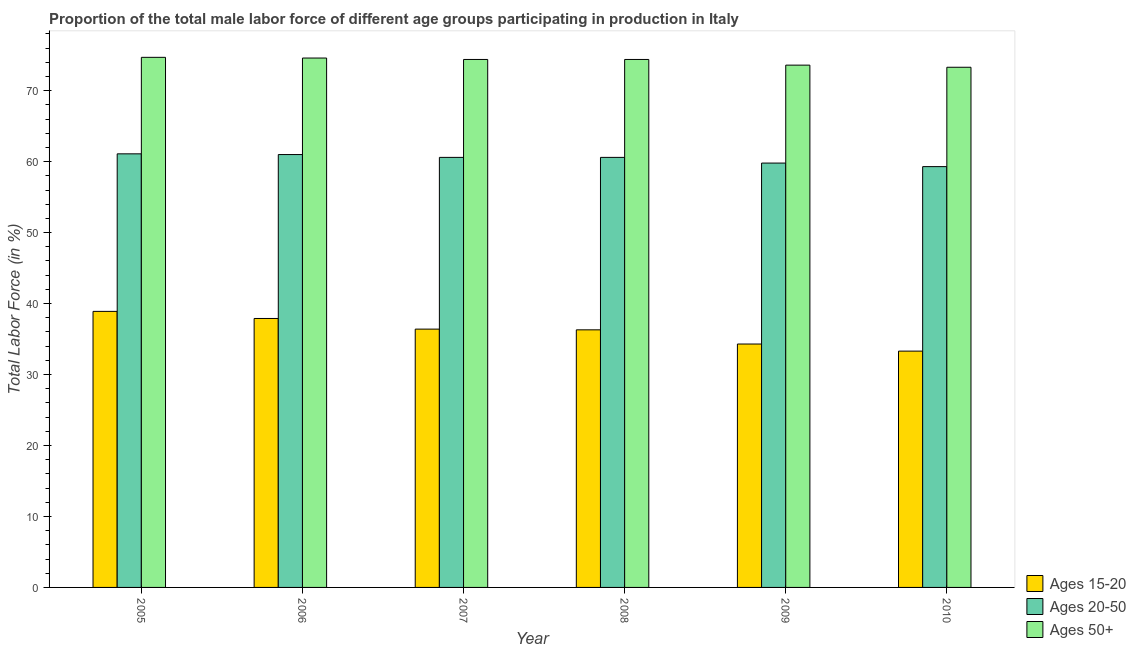How many different coloured bars are there?
Your answer should be very brief. 3. How many groups of bars are there?
Ensure brevity in your answer.  6. Are the number of bars per tick equal to the number of legend labels?
Provide a succinct answer. Yes. Are the number of bars on each tick of the X-axis equal?
Make the answer very short. Yes. How many bars are there on the 5th tick from the left?
Your answer should be very brief. 3. How many bars are there on the 2nd tick from the right?
Your answer should be compact. 3. What is the label of the 5th group of bars from the left?
Provide a short and direct response. 2009. What is the percentage of male labor force within the age group 15-20 in 2008?
Provide a succinct answer. 36.3. Across all years, what is the maximum percentage of male labor force within the age group 15-20?
Give a very brief answer. 38.9. Across all years, what is the minimum percentage of male labor force above age 50?
Provide a succinct answer. 73.3. In which year was the percentage of male labor force within the age group 20-50 maximum?
Offer a very short reply. 2005. What is the total percentage of male labor force within the age group 20-50 in the graph?
Provide a succinct answer. 362.4. What is the difference between the percentage of male labor force within the age group 15-20 in 2009 and that in 2010?
Your answer should be very brief. 1. What is the difference between the percentage of male labor force above age 50 in 2007 and the percentage of male labor force within the age group 15-20 in 2009?
Provide a succinct answer. 0.8. What is the average percentage of male labor force within the age group 20-50 per year?
Offer a very short reply. 60.4. In the year 2005, what is the difference between the percentage of male labor force above age 50 and percentage of male labor force within the age group 15-20?
Your answer should be very brief. 0. What is the ratio of the percentage of male labor force within the age group 15-20 in 2005 to that in 2007?
Keep it short and to the point. 1.07. Is the percentage of male labor force above age 50 in 2006 less than that in 2008?
Offer a terse response. No. Is the difference between the percentage of male labor force within the age group 20-50 in 2007 and 2010 greater than the difference between the percentage of male labor force within the age group 15-20 in 2007 and 2010?
Your response must be concise. No. What is the difference between the highest and the second highest percentage of male labor force within the age group 20-50?
Keep it short and to the point. 0.1. What is the difference between the highest and the lowest percentage of male labor force above age 50?
Provide a succinct answer. 1.4. In how many years, is the percentage of male labor force above age 50 greater than the average percentage of male labor force above age 50 taken over all years?
Offer a very short reply. 4. Is the sum of the percentage of male labor force within the age group 20-50 in 2008 and 2010 greater than the maximum percentage of male labor force above age 50 across all years?
Offer a very short reply. Yes. What does the 3rd bar from the left in 2007 represents?
Your answer should be compact. Ages 50+. What does the 3rd bar from the right in 2009 represents?
Make the answer very short. Ages 15-20. How many bars are there?
Your answer should be very brief. 18. Are all the bars in the graph horizontal?
Offer a terse response. No. How many years are there in the graph?
Ensure brevity in your answer.  6. Does the graph contain any zero values?
Your response must be concise. No. Does the graph contain grids?
Provide a succinct answer. No. How many legend labels are there?
Offer a terse response. 3. How are the legend labels stacked?
Your answer should be compact. Vertical. What is the title of the graph?
Keep it short and to the point. Proportion of the total male labor force of different age groups participating in production in Italy. Does "Female employers" appear as one of the legend labels in the graph?
Give a very brief answer. No. What is the label or title of the X-axis?
Make the answer very short. Year. What is the label or title of the Y-axis?
Offer a very short reply. Total Labor Force (in %). What is the Total Labor Force (in %) of Ages 15-20 in 2005?
Provide a succinct answer. 38.9. What is the Total Labor Force (in %) of Ages 20-50 in 2005?
Make the answer very short. 61.1. What is the Total Labor Force (in %) of Ages 50+ in 2005?
Provide a short and direct response. 74.7. What is the Total Labor Force (in %) in Ages 15-20 in 2006?
Keep it short and to the point. 37.9. What is the Total Labor Force (in %) of Ages 50+ in 2006?
Make the answer very short. 74.6. What is the Total Labor Force (in %) in Ages 15-20 in 2007?
Keep it short and to the point. 36.4. What is the Total Labor Force (in %) of Ages 20-50 in 2007?
Your answer should be compact. 60.6. What is the Total Labor Force (in %) in Ages 50+ in 2007?
Provide a short and direct response. 74.4. What is the Total Labor Force (in %) in Ages 15-20 in 2008?
Provide a short and direct response. 36.3. What is the Total Labor Force (in %) of Ages 20-50 in 2008?
Your response must be concise. 60.6. What is the Total Labor Force (in %) of Ages 50+ in 2008?
Provide a short and direct response. 74.4. What is the Total Labor Force (in %) of Ages 15-20 in 2009?
Your response must be concise. 34.3. What is the Total Labor Force (in %) of Ages 20-50 in 2009?
Your answer should be compact. 59.8. What is the Total Labor Force (in %) of Ages 50+ in 2009?
Keep it short and to the point. 73.6. What is the Total Labor Force (in %) in Ages 15-20 in 2010?
Offer a very short reply. 33.3. What is the Total Labor Force (in %) of Ages 20-50 in 2010?
Your answer should be compact. 59.3. What is the Total Labor Force (in %) in Ages 50+ in 2010?
Offer a very short reply. 73.3. Across all years, what is the maximum Total Labor Force (in %) in Ages 15-20?
Offer a very short reply. 38.9. Across all years, what is the maximum Total Labor Force (in %) in Ages 20-50?
Your answer should be compact. 61.1. Across all years, what is the maximum Total Labor Force (in %) of Ages 50+?
Offer a terse response. 74.7. Across all years, what is the minimum Total Labor Force (in %) of Ages 15-20?
Offer a terse response. 33.3. Across all years, what is the minimum Total Labor Force (in %) in Ages 20-50?
Make the answer very short. 59.3. Across all years, what is the minimum Total Labor Force (in %) in Ages 50+?
Offer a very short reply. 73.3. What is the total Total Labor Force (in %) of Ages 15-20 in the graph?
Ensure brevity in your answer.  217.1. What is the total Total Labor Force (in %) in Ages 20-50 in the graph?
Offer a terse response. 362.4. What is the total Total Labor Force (in %) of Ages 50+ in the graph?
Provide a short and direct response. 445. What is the difference between the Total Labor Force (in %) in Ages 20-50 in 2005 and that in 2006?
Offer a very short reply. 0.1. What is the difference between the Total Labor Force (in %) in Ages 50+ in 2005 and that in 2008?
Keep it short and to the point. 0.3. What is the difference between the Total Labor Force (in %) of Ages 15-20 in 2005 and that in 2009?
Your answer should be compact. 4.6. What is the difference between the Total Labor Force (in %) in Ages 50+ in 2005 and that in 2009?
Make the answer very short. 1.1. What is the difference between the Total Labor Force (in %) of Ages 15-20 in 2005 and that in 2010?
Keep it short and to the point. 5.6. What is the difference between the Total Labor Force (in %) in Ages 50+ in 2005 and that in 2010?
Your answer should be compact. 1.4. What is the difference between the Total Labor Force (in %) of Ages 15-20 in 2006 and that in 2007?
Keep it short and to the point. 1.5. What is the difference between the Total Labor Force (in %) of Ages 20-50 in 2006 and that in 2007?
Offer a very short reply. 0.4. What is the difference between the Total Labor Force (in %) in Ages 15-20 in 2006 and that in 2009?
Your answer should be compact. 3.6. What is the difference between the Total Labor Force (in %) in Ages 15-20 in 2006 and that in 2010?
Ensure brevity in your answer.  4.6. What is the difference between the Total Labor Force (in %) of Ages 20-50 in 2006 and that in 2010?
Ensure brevity in your answer.  1.7. What is the difference between the Total Labor Force (in %) of Ages 20-50 in 2007 and that in 2008?
Provide a short and direct response. 0. What is the difference between the Total Labor Force (in %) in Ages 15-20 in 2007 and that in 2009?
Ensure brevity in your answer.  2.1. What is the difference between the Total Labor Force (in %) of Ages 20-50 in 2007 and that in 2009?
Keep it short and to the point. 0.8. What is the difference between the Total Labor Force (in %) in Ages 20-50 in 2007 and that in 2010?
Give a very brief answer. 1.3. What is the difference between the Total Labor Force (in %) of Ages 20-50 in 2008 and that in 2009?
Keep it short and to the point. 0.8. What is the difference between the Total Labor Force (in %) of Ages 15-20 in 2008 and that in 2010?
Provide a succinct answer. 3. What is the difference between the Total Labor Force (in %) of Ages 15-20 in 2009 and that in 2010?
Your response must be concise. 1. What is the difference between the Total Labor Force (in %) of Ages 50+ in 2009 and that in 2010?
Your response must be concise. 0.3. What is the difference between the Total Labor Force (in %) of Ages 15-20 in 2005 and the Total Labor Force (in %) of Ages 20-50 in 2006?
Your response must be concise. -22.1. What is the difference between the Total Labor Force (in %) of Ages 15-20 in 2005 and the Total Labor Force (in %) of Ages 50+ in 2006?
Offer a very short reply. -35.7. What is the difference between the Total Labor Force (in %) of Ages 15-20 in 2005 and the Total Labor Force (in %) of Ages 20-50 in 2007?
Offer a terse response. -21.7. What is the difference between the Total Labor Force (in %) in Ages 15-20 in 2005 and the Total Labor Force (in %) in Ages 50+ in 2007?
Your answer should be compact. -35.5. What is the difference between the Total Labor Force (in %) of Ages 15-20 in 2005 and the Total Labor Force (in %) of Ages 20-50 in 2008?
Give a very brief answer. -21.7. What is the difference between the Total Labor Force (in %) in Ages 15-20 in 2005 and the Total Labor Force (in %) in Ages 50+ in 2008?
Your answer should be very brief. -35.5. What is the difference between the Total Labor Force (in %) in Ages 20-50 in 2005 and the Total Labor Force (in %) in Ages 50+ in 2008?
Your answer should be compact. -13.3. What is the difference between the Total Labor Force (in %) in Ages 15-20 in 2005 and the Total Labor Force (in %) in Ages 20-50 in 2009?
Make the answer very short. -20.9. What is the difference between the Total Labor Force (in %) in Ages 15-20 in 2005 and the Total Labor Force (in %) in Ages 50+ in 2009?
Ensure brevity in your answer.  -34.7. What is the difference between the Total Labor Force (in %) in Ages 20-50 in 2005 and the Total Labor Force (in %) in Ages 50+ in 2009?
Your response must be concise. -12.5. What is the difference between the Total Labor Force (in %) of Ages 15-20 in 2005 and the Total Labor Force (in %) of Ages 20-50 in 2010?
Your response must be concise. -20.4. What is the difference between the Total Labor Force (in %) of Ages 15-20 in 2005 and the Total Labor Force (in %) of Ages 50+ in 2010?
Provide a succinct answer. -34.4. What is the difference between the Total Labor Force (in %) in Ages 15-20 in 2006 and the Total Labor Force (in %) in Ages 20-50 in 2007?
Provide a short and direct response. -22.7. What is the difference between the Total Labor Force (in %) in Ages 15-20 in 2006 and the Total Labor Force (in %) in Ages 50+ in 2007?
Your response must be concise. -36.5. What is the difference between the Total Labor Force (in %) in Ages 20-50 in 2006 and the Total Labor Force (in %) in Ages 50+ in 2007?
Your answer should be compact. -13.4. What is the difference between the Total Labor Force (in %) of Ages 15-20 in 2006 and the Total Labor Force (in %) of Ages 20-50 in 2008?
Ensure brevity in your answer.  -22.7. What is the difference between the Total Labor Force (in %) of Ages 15-20 in 2006 and the Total Labor Force (in %) of Ages 50+ in 2008?
Ensure brevity in your answer.  -36.5. What is the difference between the Total Labor Force (in %) in Ages 20-50 in 2006 and the Total Labor Force (in %) in Ages 50+ in 2008?
Keep it short and to the point. -13.4. What is the difference between the Total Labor Force (in %) in Ages 15-20 in 2006 and the Total Labor Force (in %) in Ages 20-50 in 2009?
Provide a succinct answer. -21.9. What is the difference between the Total Labor Force (in %) of Ages 15-20 in 2006 and the Total Labor Force (in %) of Ages 50+ in 2009?
Offer a very short reply. -35.7. What is the difference between the Total Labor Force (in %) of Ages 20-50 in 2006 and the Total Labor Force (in %) of Ages 50+ in 2009?
Make the answer very short. -12.6. What is the difference between the Total Labor Force (in %) in Ages 15-20 in 2006 and the Total Labor Force (in %) in Ages 20-50 in 2010?
Ensure brevity in your answer.  -21.4. What is the difference between the Total Labor Force (in %) in Ages 15-20 in 2006 and the Total Labor Force (in %) in Ages 50+ in 2010?
Your response must be concise. -35.4. What is the difference between the Total Labor Force (in %) in Ages 15-20 in 2007 and the Total Labor Force (in %) in Ages 20-50 in 2008?
Keep it short and to the point. -24.2. What is the difference between the Total Labor Force (in %) of Ages 15-20 in 2007 and the Total Labor Force (in %) of Ages 50+ in 2008?
Provide a short and direct response. -38. What is the difference between the Total Labor Force (in %) in Ages 20-50 in 2007 and the Total Labor Force (in %) in Ages 50+ in 2008?
Your answer should be compact. -13.8. What is the difference between the Total Labor Force (in %) of Ages 15-20 in 2007 and the Total Labor Force (in %) of Ages 20-50 in 2009?
Your answer should be very brief. -23.4. What is the difference between the Total Labor Force (in %) of Ages 15-20 in 2007 and the Total Labor Force (in %) of Ages 50+ in 2009?
Your answer should be very brief. -37.2. What is the difference between the Total Labor Force (in %) of Ages 20-50 in 2007 and the Total Labor Force (in %) of Ages 50+ in 2009?
Provide a succinct answer. -13. What is the difference between the Total Labor Force (in %) in Ages 15-20 in 2007 and the Total Labor Force (in %) in Ages 20-50 in 2010?
Your answer should be compact. -22.9. What is the difference between the Total Labor Force (in %) of Ages 15-20 in 2007 and the Total Labor Force (in %) of Ages 50+ in 2010?
Keep it short and to the point. -36.9. What is the difference between the Total Labor Force (in %) of Ages 20-50 in 2007 and the Total Labor Force (in %) of Ages 50+ in 2010?
Your answer should be very brief. -12.7. What is the difference between the Total Labor Force (in %) in Ages 15-20 in 2008 and the Total Labor Force (in %) in Ages 20-50 in 2009?
Provide a short and direct response. -23.5. What is the difference between the Total Labor Force (in %) in Ages 15-20 in 2008 and the Total Labor Force (in %) in Ages 50+ in 2009?
Offer a terse response. -37.3. What is the difference between the Total Labor Force (in %) of Ages 20-50 in 2008 and the Total Labor Force (in %) of Ages 50+ in 2009?
Your answer should be very brief. -13. What is the difference between the Total Labor Force (in %) of Ages 15-20 in 2008 and the Total Labor Force (in %) of Ages 20-50 in 2010?
Offer a very short reply. -23. What is the difference between the Total Labor Force (in %) of Ages 15-20 in 2008 and the Total Labor Force (in %) of Ages 50+ in 2010?
Offer a very short reply. -37. What is the difference between the Total Labor Force (in %) of Ages 15-20 in 2009 and the Total Labor Force (in %) of Ages 20-50 in 2010?
Your response must be concise. -25. What is the difference between the Total Labor Force (in %) in Ages 15-20 in 2009 and the Total Labor Force (in %) in Ages 50+ in 2010?
Keep it short and to the point. -39. What is the difference between the Total Labor Force (in %) of Ages 20-50 in 2009 and the Total Labor Force (in %) of Ages 50+ in 2010?
Provide a short and direct response. -13.5. What is the average Total Labor Force (in %) in Ages 15-20 per year?
Provide a succinct answer. 36.18. What is the average Total Labor Force (in %) in Ages 20-50 per year?
Ensure brevity in your answer.  60.4. What is the average Total Labor Force (in %) of Ages 50+ per year?
Provide a succinct answer. 74.17. In the year 2005, what is the difference between the Total Labor Force (in %) in Ages 15-20 and Total Labor Force (in %) in Ages 20-50?
Offer a very short reply. -22.2. In the year 2005, what is the difference between the Total Labor Force (in %) of Ages 15-20 and Total Labor Force (in %) of Ages 50+?
Provide a short and direct response. -35.8. In the year 2006, what is the difference between the Total Labor Force (in %) of Ages 15-20 and Total Labor Force (in %) of Ages 20-50?
Your answer should be very brief. -23.1. In the year 2006, what is the difference between the Total Labor Force (in %) of Ages 15-20 and Total Labor Force (in %) of Ages 50+?
Provide a short and direct response. -36.7. In the year 2007, what is the difference between the Total Labor Force (in %) of Ages 15-20 and Total Labor Force (in %) of Ages 20-50?
Provide a succinct answer. -24.2. In the year 2007, what is the difference between the Total Labor Force (in %) in Ages 15-20 and Total Labor Force (in %) in Ages 50+?
Your answer should be very brief. -38. In the year 2008, what is the difference between the Total Labor Force (in %) of Ages 15-20 and Total Labor Force (in %) of Ages 20-50?
Offer a very short reply. -24.3. In the year 2008, what is the difference between the Total Labor Force (in %) in Ages 15-20 and Total Labor Force (in %) in Ages 50+?
Offer a very short reply. -38.1. In the year 2008, what is the difference between the Total Labor Force (in %) of Ages 20-50 and Total Labor Force (in %) of Ages 50+?
Provide a succinct answer. -13.8. In the year 2009, what is the difference between the Total Labor Force (in %) of Ages 15-20 and Total Labor Force (in %) of Ages 20-50?
Your answer should be compact. -25.5. In the year 2009, what is the difference between the Total Labor Force (in %) of Ages 15-20 and Total Labor Force (in %) of Ages 50+?
Provide a short and direct response. -39.3. In the year 2010, what is the difference between the Total Labor Force (in %) of Ages 15-20 and Total Labor Force (in %) of Ages 50+?
Your answer should be compact. -40. What is the ratio of the Total Labor Force (in %) in Ages 15-20 in 2005 to that in 2006?
Offer a terse response. 1.03. What is the ratio of the Total Labor Force (in %) in Ages 50+ in 2005 to that in 2006?
Your response must be concise. 1. What is the ratio of the Total Labor Force (in %) in Ages 15-20 in 2005 to that in 2007?
Make the answer very short. 1.07. What is the ratio of the Total Labor Force (in %) of Ages 20-50 in 2005 to that in 2007?
Provide a short and direct response. 1.01. What is the ratio of the Total Labor Force (in %) in Ages 15-20 in 2005 to that in 2008?
Provide a short and direct response. 1.07. What is the ratio of the Total Labor Force (in %) in Ages 20-50 in 2005 to that in 2008?
Provide a succinct answer. 1.01. What is the ratio of the Total Labor Force (in %) in Ages 15-20 in 2005 to that in 2009?
Your answer should be very brief. 1.13. What is the ratio of the Total Labor Force (in %) in Ages 20-50 in 2005 to that in 2009?
Ensure brevity in your answer.  1.02. What is the ratio of the Total Labor Force (in %) in Ages 50+ in 2005 to that in 2009?
Offer a very short reply. 1.01. What is the ratio of the Total Labor Force (in %) of Ages 15-20 in 2005 to that in 2010?
Provide a short and direct response. 1.17. What is the ratio of the Total Labor Force (in %) of Ages 20-50 in 2005 to that in 2010?
Keep it short and to the point. 1.03. What is the ratio of the Total Labor Force (in %) in Ages 50+ in 2005 to that in 2010?
Provide a succinct answer. 1.02. What is the ratio of the Total Labor Force (in %) in Ages 15-20 in 2006 to that in 2007?
Provide a succinct answer. 1.04. What is the ratio of the Total Labor Force (in %) in Ages 20-50 in 2006 to that in 2007?
Keep it short and to the point. 1.01. What is the ratio of the Total Labor Force (in %) in Ages 50+ in 2006 to that in 2007?
Offer a very short reply. 1. What is the ratio of the Total Labor Force (in %) in Ages 15-20 in 2006 to that in 2008?
Your answer should be compact. 1.04. What is the ratio of the Total Labor Force (in %) in Ages 20-50 in 2006 to that in 2008?
Provide a short and direct response. 1.01. What is the ratio of the Total Labor Force (in %) in Ages 50+ in 2006 to that in 2008?
Make the answer very short. 1. What is the ratio of the Total Labor Force (in %) in Ages 15-20 in 2006 to that in 2009?
Your answer should be compact. 1.1. What is the ratio of the Total Labor Force (in %) of Ages 20-50 in 2006 to that in 2009?
Your response must be concise. 1.02. What is the ratio of the Total Labor Force (in %) in Ages 50+ in 2006 to that in 2009?
Ensure brevity in your answer.  1.01. What is the ratio of the Total Labor Force (in %) in Ages 15-20 in 2006 to that in 2010?
Your answer should be very brief. 1.14. What is the ratio of the Total Labor Force (in %) in Ages 20-50 in 2006 to that in 2010?
Offer a terse response. 1.03. What is the ratio of the Total Labor Force (in %) in Ages 50+ in 2006 to that in 2010?
Offer a very short reply. 1.02. What is the ratio of the Total Labor Force (in %) in Ages 15-20 in 2007 to that in 2008?
Make the answer very short. 1. What is the ratio of the Total Labor Force (in %) of Ages 20-50 in 2007 to that in 2008?
Ensure brevity in your answer.  1. What is the ratio of the Total Labor Force (in %) of Ages 50+ in 2007 to that in 2008?
Provide a succinct answer. 1. What is the ratio of the Total Labor Force (in %) of Ages 15-20 in 2007 to that in 2009?
Make the answer very short. 1.06. What is the ratio of the Total Labor Force (in %) of Ages 20-50 in 2007 to that in 2009?
Make the answer very short. 1.01. What is the ratio of the Total Labor Force (in %) of Ages 50+ in 2007 to that in 2009?
Ensure brevity in your answer.  1.01. What is the ratio of the Total Labor Force (in %) in Ages 15-20 in 2007 to that in 2010?
Offer a very short reply. 1.09. What is the ratio of the Total Labor Force (in %) in Ages 20-50 in 2007 to that in 2010?
Offer a terse response. 1.02. What is the ratio of the Total Labor Force (in %) in Ages 50+ in 2007 to that in 2010?
Your answer should be very brief. 1.01. What is the ratio of the Total Labor Force (in %) of Ages 15-20 in 2008 to that in 2009?
Your answer should be very brief. 1.06. What is the ratio of the Total Labor Force (in %) in Ages 20-50 in 2008 to that in 2009?
Your answer should be compact. 1.01. What is the ratio of the Total Labor Force (in %) of Ages 50+ in 2008 to that in 2009?
Your answer should be very brief. 1.01. What is the ratio of the Total Labor Force (in %) in Ages 15-20 in 2008 to that in 2010?
Offer a very short reply. 1.09. What is the ratio of the Total Labor Force (in %) of Ages 20-50 in 2008 to that in 2010?
Provide a short and direct response. 1.02. What is the ratio of the Total Labor Force (in %) in Ages 50+ in 2008 to that in 2010?
Offer a terse response. 1.01. What is the ratio of the Total Labor Force (in %) in Ages 20-50 in 2009 to that in 2010?
Offer a terse response. 1.01. What is the ratio of the Total Labor Force (in %) in Ages 50+ in 2009 to that in 2010?
Provide a succinct answer. 1. What is the difference between the highest and the second highest Total Labor Force (in %) in Ages 15-20?
Your response must be concise. 1. What is the difference between the highest and the second highest Total Labor Force (in %) of Ages 50+?
Make the answer very short. 0.1. What is the difference between the highest and the lowest Total Labor Force (in %) of Ages 20-50?
Your answer should be very brief. 1.8. 